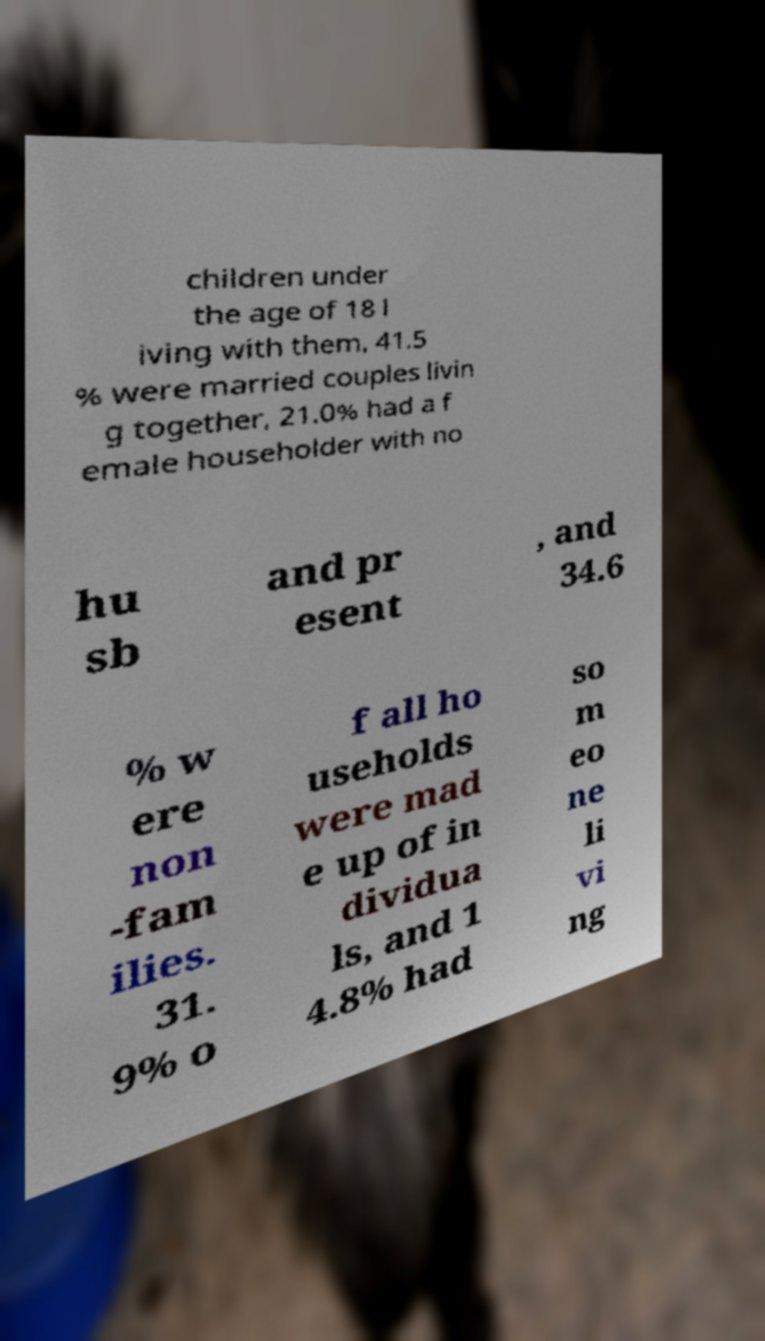Can you accurately transcribe the text from the provided image for me? children under the age of 18 l iving with them, 41.5 % were married couples livin g together, 21.0% had a f emale householder with no hu sb and pr esent , and 34.6 % w ere non -fam ilies. 31. 9% o f all ho useholds were mad e up of in dividua ls, and 1 4.8% had so m eo ne li vi ng 